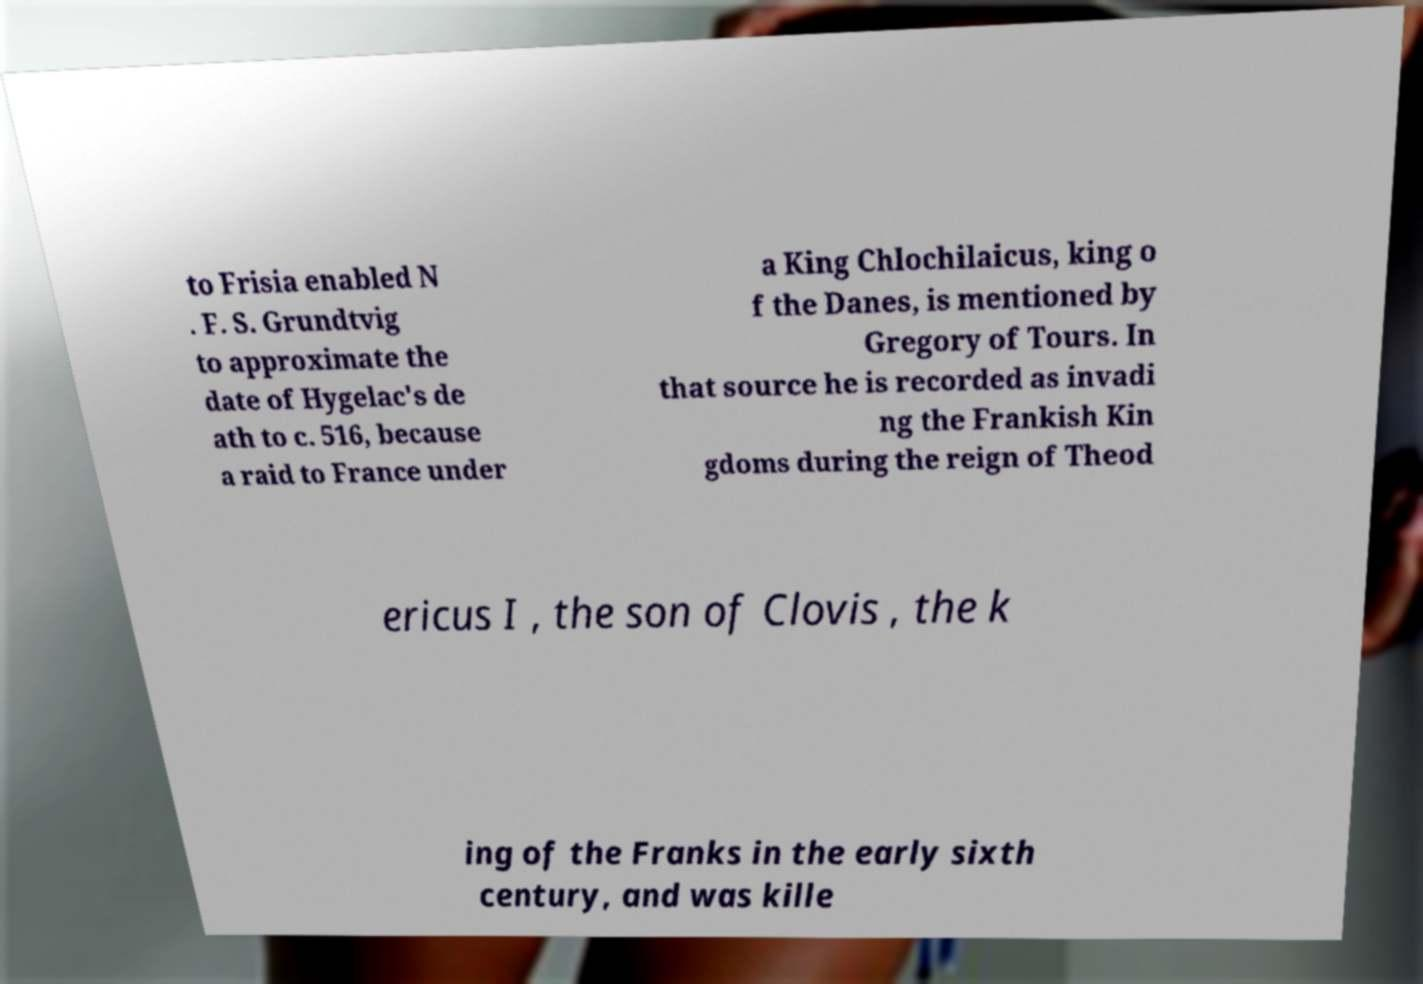There's text embedded in this image that I need extracted. Can you transcribe it verbatim? to Frisia enabled N . F. S. Grundtvig to approximate the date of Hygelac's de ath to c. 516, because a raid to France under a King Chlochilaicus, king o f the Danes, is mentioned by Gregory of Tours. In that source he is recorded as invadi ng the Frankish Kin gdoms during the reign of Theod ericus I , the son of Clovis , the k ing of the Franks in the early sixth century, and was kille 